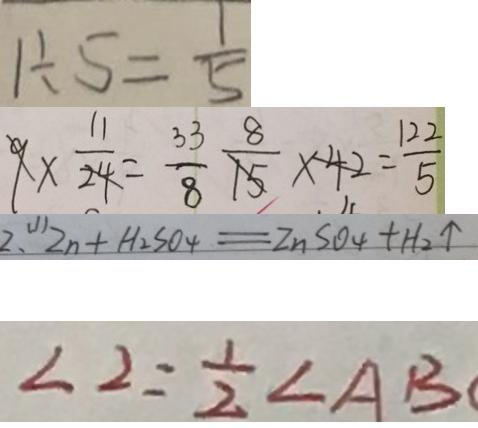Convert formula to latex. <formula><loc_0><loc_0><loc_500><loc_500>1 \div 5 = \frac { 1 } { 5 } 
 9 \times \frac { 1 1 } { 2 4 } = \frac { 3 3 } { 8 } \frac { 8 } { 1 5 } \times 4 2 = \frac { 1 2 2 } { 5 } 
 2 . ( 1 ) Z n + H _ { 2 } S O _ { 4 } = Z n S O _ { 4 } + H _ { 2 } \uparrow 
 \angle 2 = \frac { 1 } { 2 } \angle A B</formula> 